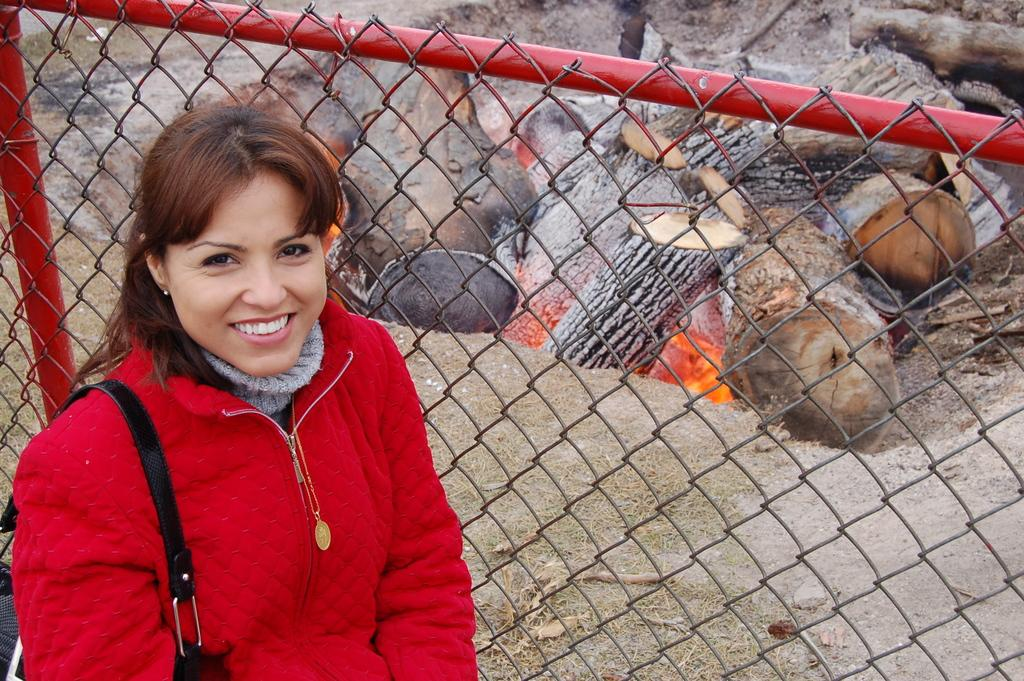What is the woman in the image wearing? The woman is wearing a red dress. What expression does the woman have? The woman is smiling. What material is the fencing in the image made of? The fencing in the image is made of metal. Can the ground be seen in the image? Yes, the ground is visible in the image. What is on fire in the image? There are wooden logs on fire in the image. What type of ink can be seen dripping from the woman's dress in the image? There is no ink dripping from the woman's dress in the image. 